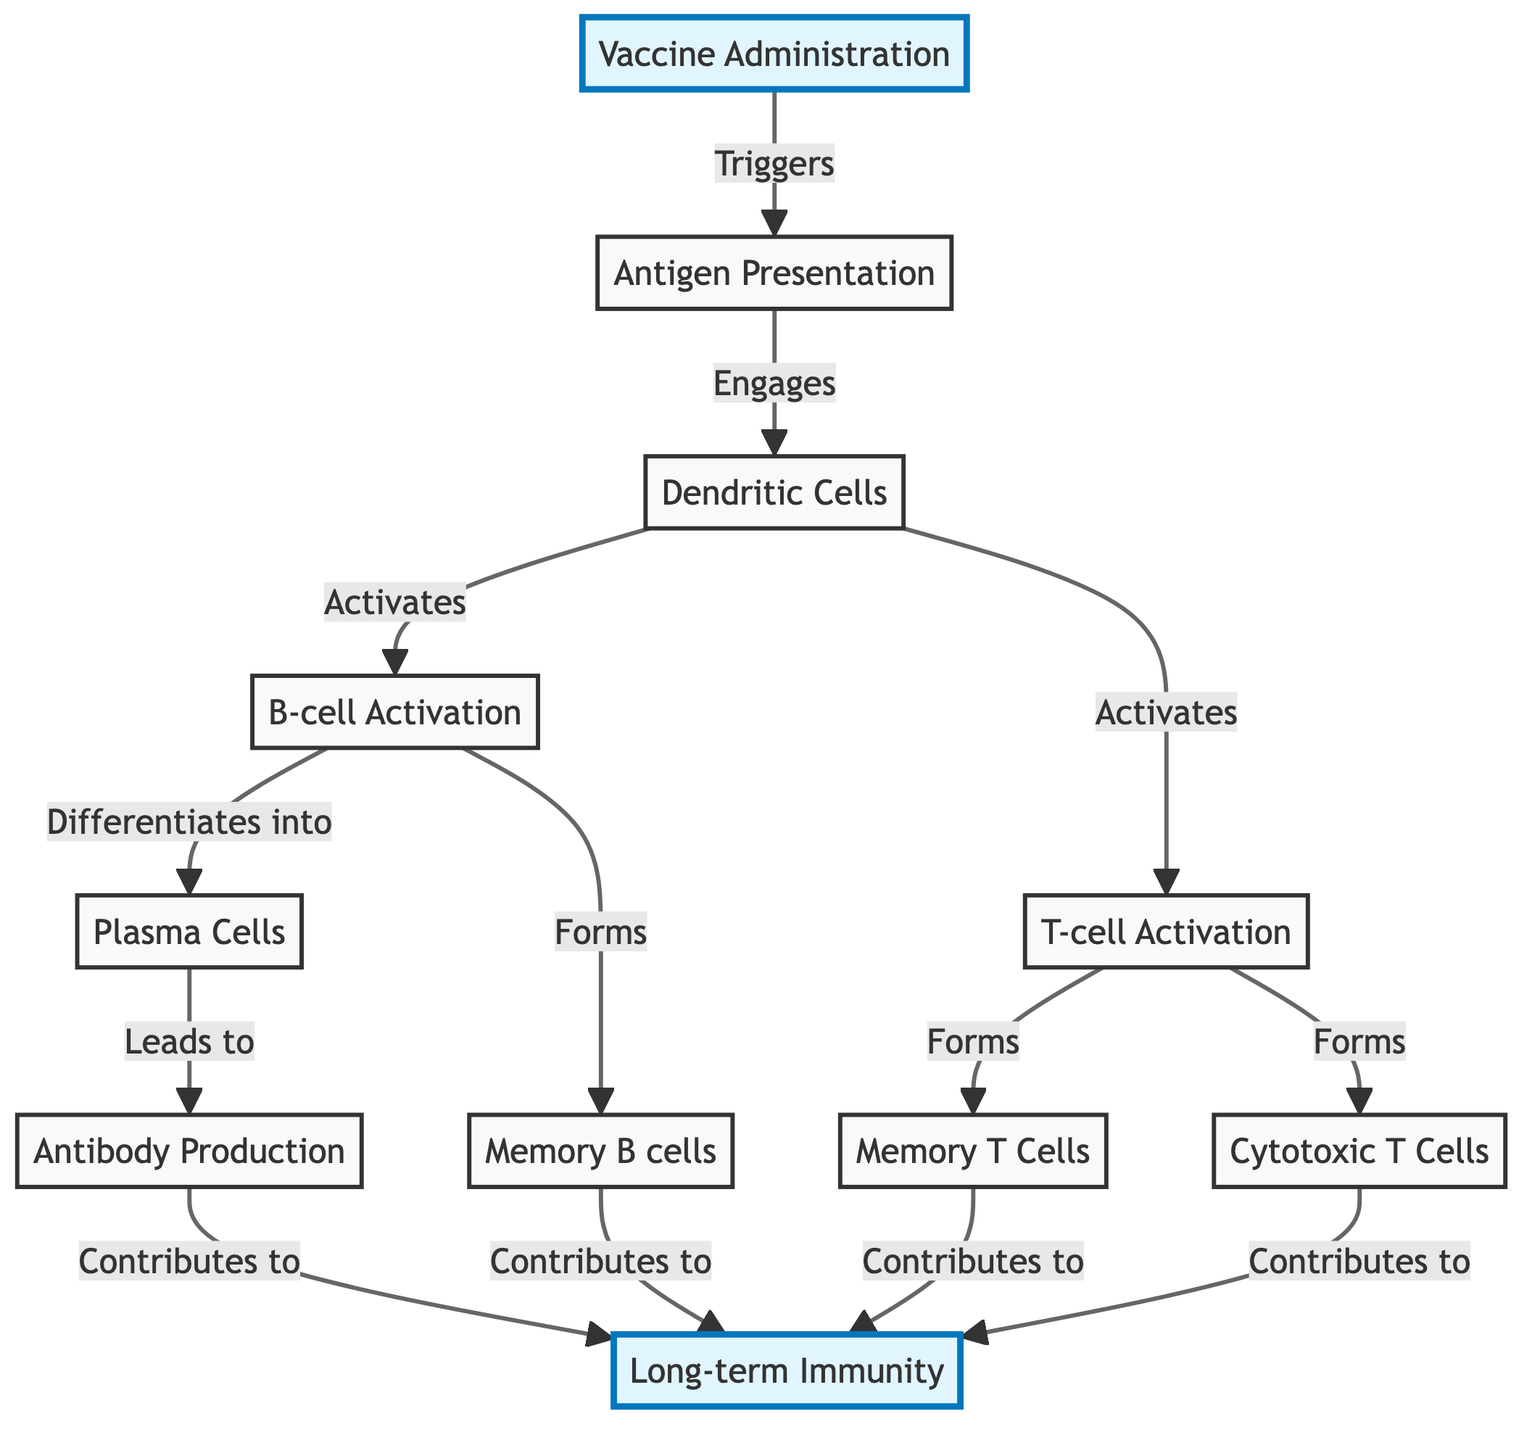What triggers the antigen presentation? According to the diagram, the process of antigen presentation is triggered by vaccine administration. The flow shows an arrow from the "Vaccine Administration" node to the "Antigen Presentation" node.
Answer: Vaccine Administration How many active cell types are formed from T-cell activation? The diagram indicates that T-cell activation leads to the formation of two types of active cells: cytotoxic T cells and memory T cells. This can be counted as two distinct outputs from the T-cell activation node.
Answer: Two What do plasma cells produce? The diagram specifies that plasma cells lead to antibody production, indicating that this is the primary function of plasma cells in the context of the immune response.
Answer: Antibodies Which cells contribute to long-term immunity? From the diagram, memory B cells, memory T cells, cytotoxic T cells, and antibody production are all shown to contribute to the long-term immunity node, making these key contributors in the immune memory response.
Answer: Memory B cells, Memory T cells, Cytotoxic T Cells, Antibody Production What engages dendritic cells? The diagram shows that dendritic cells are engaged through the process of antigen presentation. This is represented by the arrow pointing from antigen presentation to dendritic cells, indicating the direct relationship.
Answer: Antigen Presentation What is the first step in the immune response to vaccinations? According to the diagram, the first step is the "Vaccine Administration," which initiates the overall process of the immune response as indicated by the starting node of the flowchart.
Answer: Vaccine Administration How do B cells differentiate during immune activation? The flowchart indicates that B-cell activation leads to their differentiation into plasma cells, which is a direct consequence of their activation as shown in the directed flow from B-cell activation.
Answer: Plasma Cells Which cell type is primarily responsible for direct killing of infected cells? The diagram states that cytotoxic T cells are responsible for this function, as indicated by their specific role in the immune response shown in the connections from the T-cell activation node.
Answer: Cytotoxic T Cells 